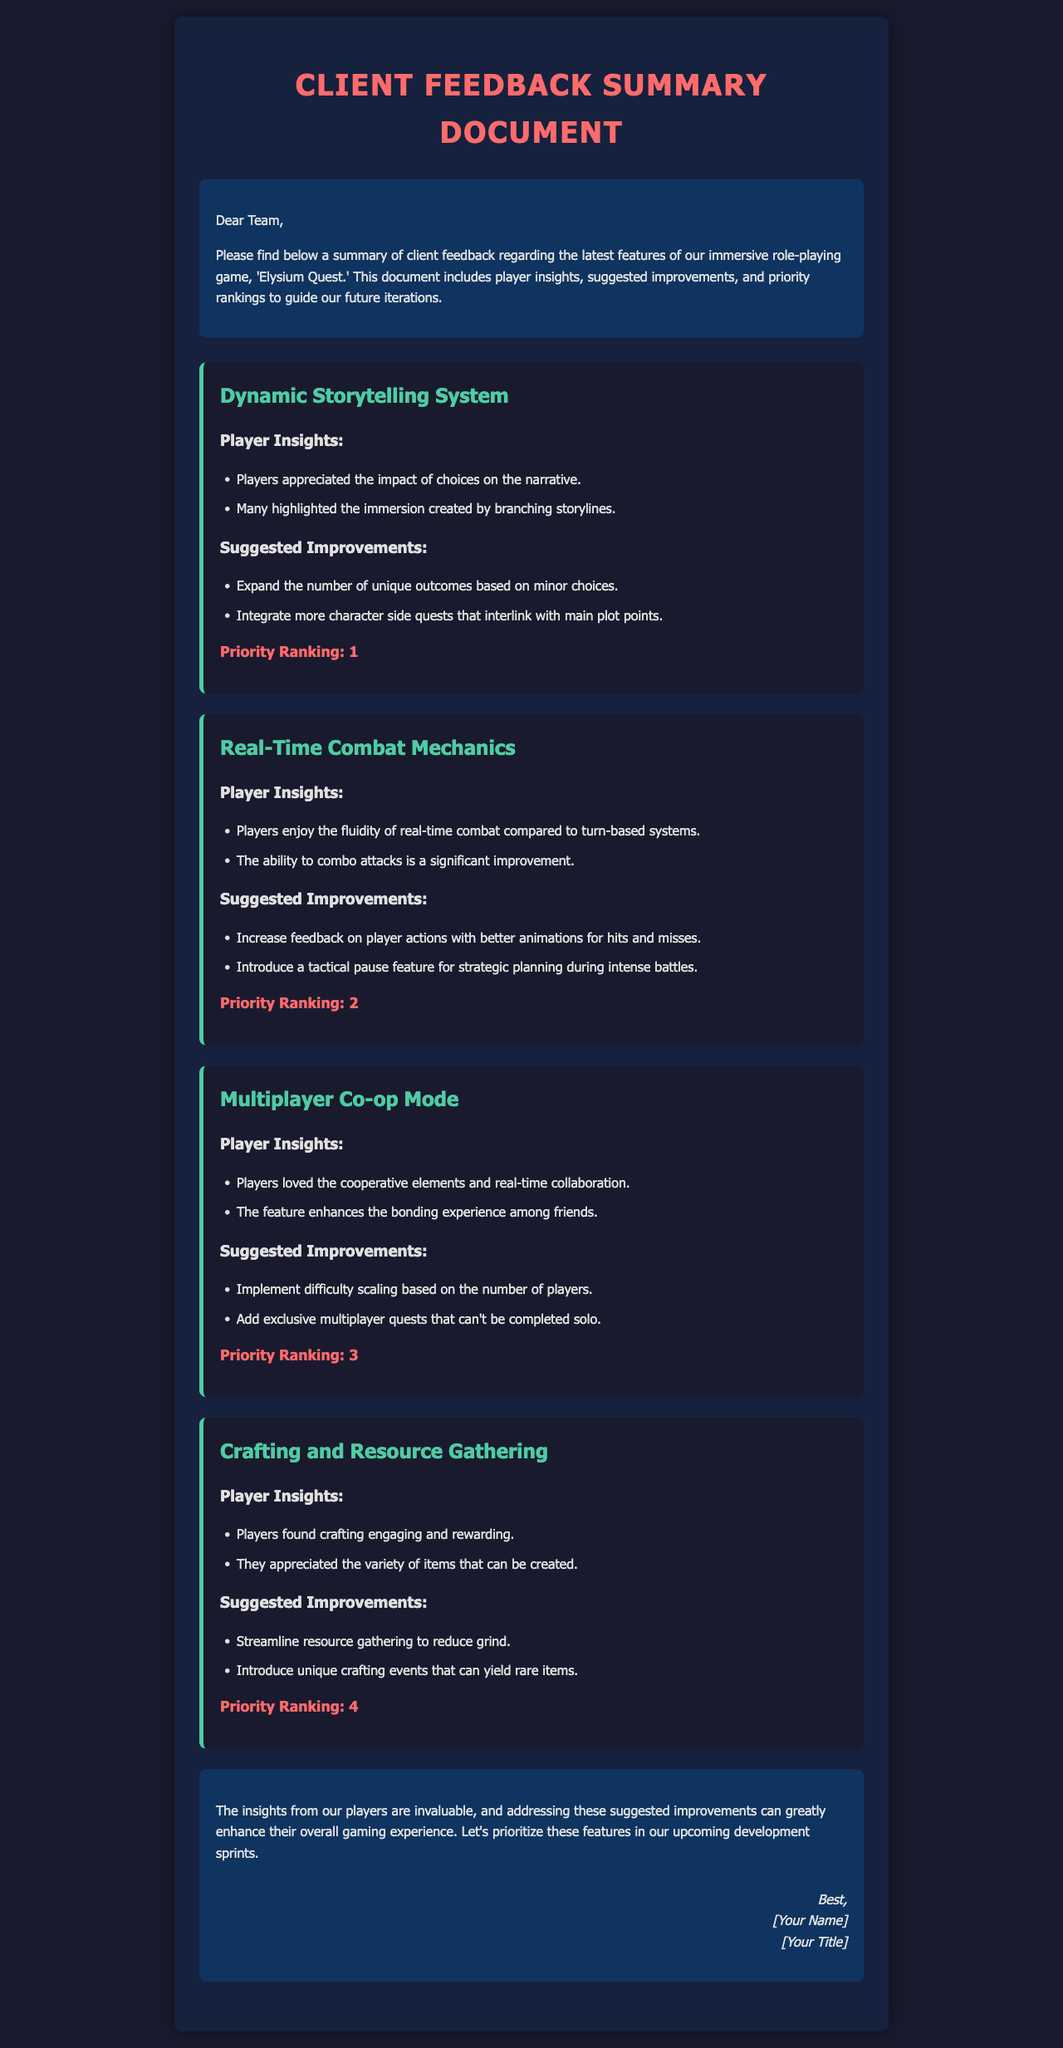What is the title of the document? The title appears at the top of the document, which is "Client Feedback Summary Document."
Answer: Client Feedback Summary Document How many feedback items are included in the document? Each feedback item is listed separately, and there are four presented in the document.
Answer: 4 What is the priority ranking of the Dynamic Storytelling System? The priority ranking is explicitly mentioned under the feedback item for the Dynamic Storytelling System.
Answer: 1 What suggested improvement is made for the Real-Time Combat Mechanics? The improvements listed under the Real-Time Combat Mechanics include multiple suggestions; one is specifically about feedback on player actions.
Answer: Increase feedback on player actions What do players think about the Multiplayer Co-op Mode? The document lists player insights, one of which states that players enjoyed real-time collaboration.
Answer: Real-time collaboration Which feature has the lowest priority ranking? The priority rankings are numbered, and the lowest ranking feature is found at the end of the list.
Answer: Crafting and Resource Gathering What is a suggested improvement for the Crafting and Resource Gathering feature? The document outlines suggested improvements, one of which mentions streamlining resource gathering.
Answer: Streamline resource gathering Which area did players appreciate the most in the feedback summary? The feedback summary shows player insights with a consistent theme of appreciation; one standout area is the dynamics of storytelling.
Answer: Dynamic Storytelling System What is stated in the conclusion of the document? The conclusion summarizes the insights and emphasizes the importance of addressing the suggested improvements.
Answer: Addressing these suggested improvements can greatly enhance their overall gaming experience 